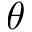<formula> <loc_0><loc_0><loc_500><loc_500>\theta</formula> 